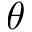<formula> <loc_0><loc_0><loc_500><loc_500>\theta</formula> 